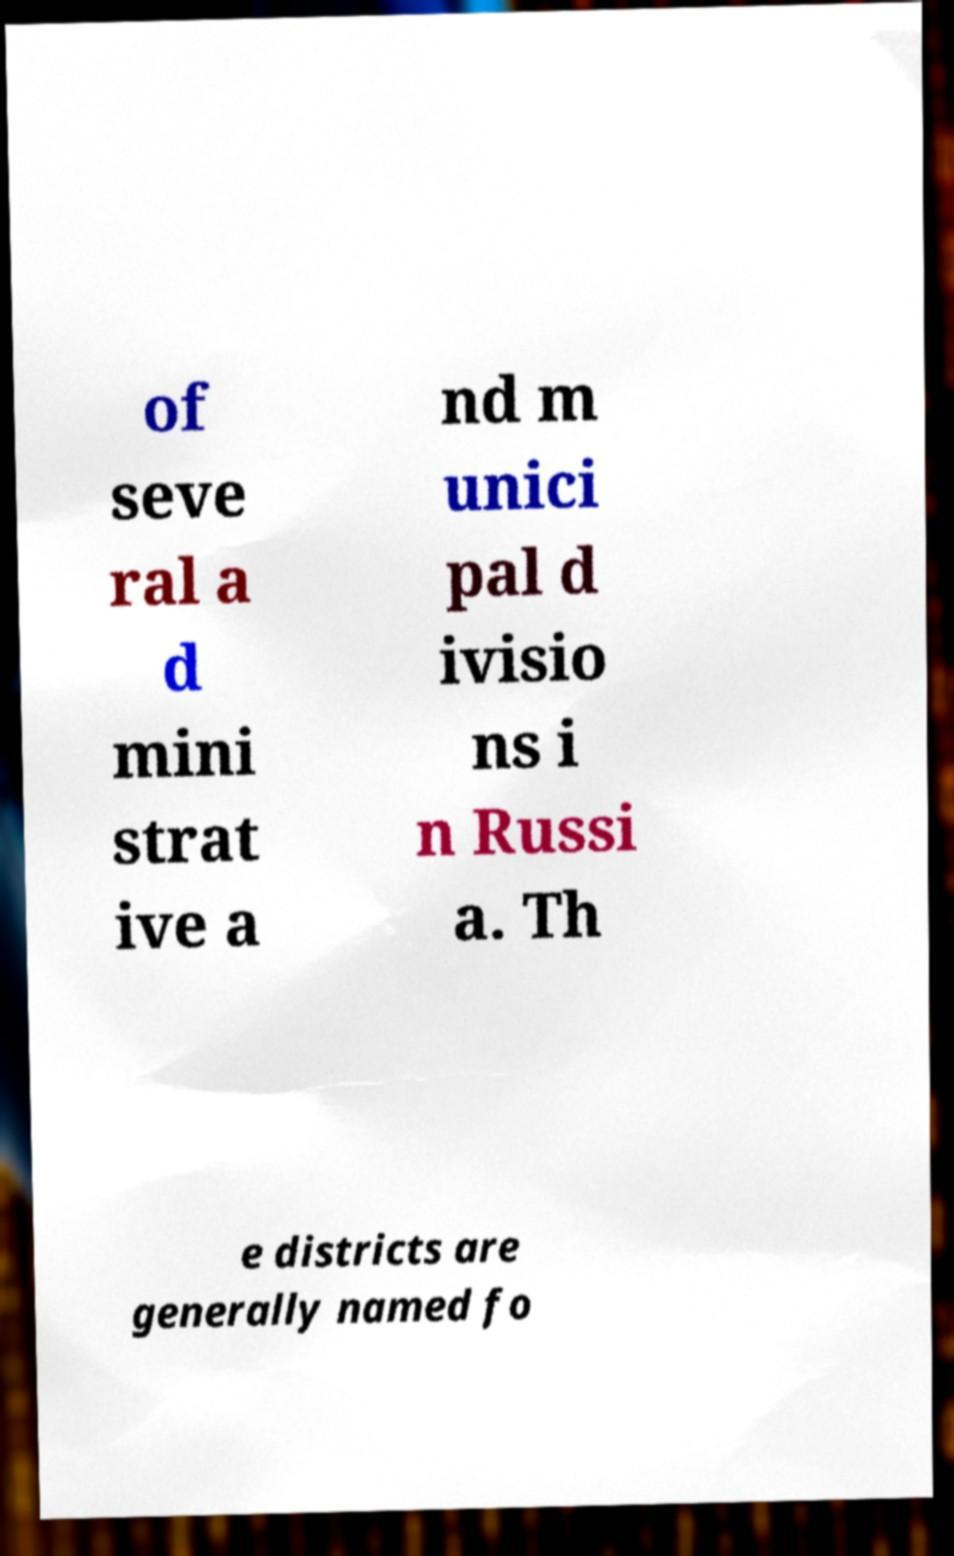Please read and relay the text visible in this image. What does it say? of seve ral a d mini strat ive a nd m unici pal d ivisio ns i n Russi a. Th e districts are generally named fo 